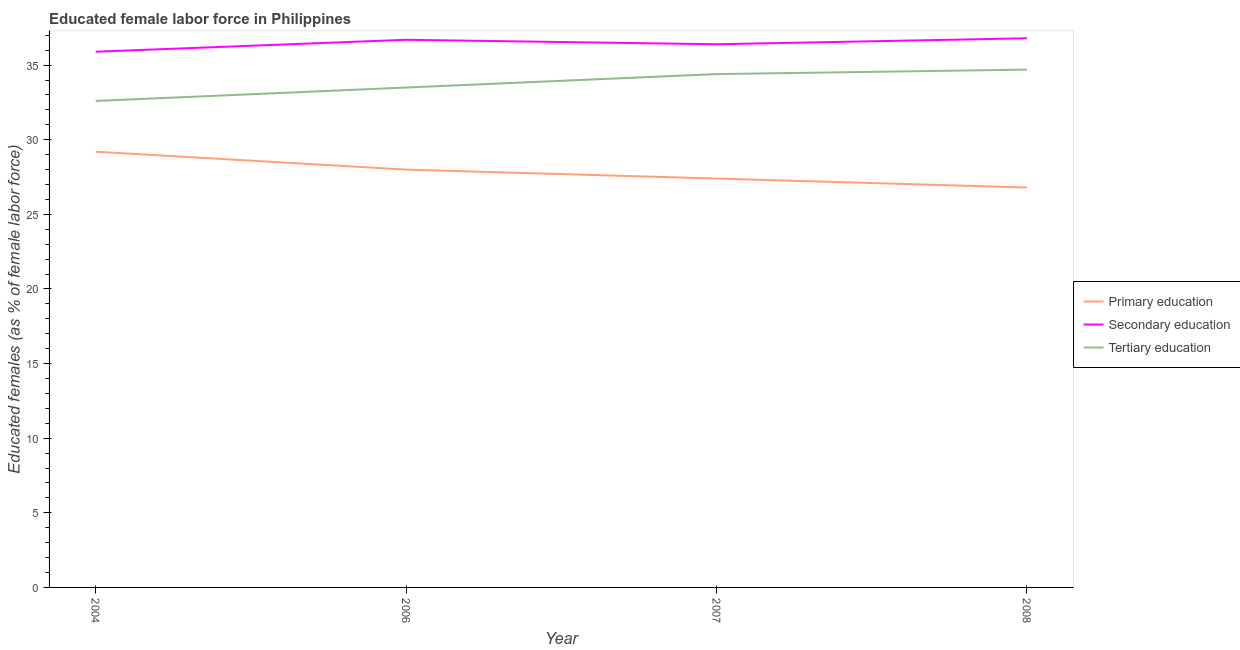Does the line corresponding to percentage of female labor force who received primary education intersect with the line corresponding to percentage of female labor force who received tertiary education?
Provide a short and direct response. No. What is the percentage of female labor force who received primary education in 2008?
Provide a succinct answer. 26.8. Across all years, what is the maximum percentage of female labor force who received secondary education?
Give a very brief answer. 36.8. Across all years, what is the minimum percentage of female labor force who received tertiary education?
Offer a very short reply. 32.6. What is the total percentage of female labor force who received secondary education in the graph?
Keep it short and to the point. 145.8. What is the difference between the percentage of female labor force who received secondary education in 2006 and that in 2008?
Keep it short and to the point. -0.1. What is the difference between the percentage of female labor force who received secondary education in 2007 and the percentage of female labor force who received tertiary education in 2006?
Provide a short and direct response. 2.9. What is the average percentage of female labor force who received tertiary education per year?
Offer a terse response. 33.8. In the year 2004, what is the difference between the percentage of female labor force who received secondary education and percentage of female labor force who received primary education?
Keep it short and to the point. 6.7. In how many years, is the percentage of female labor force who received secondary education greater than 29 %?
Provide a short and direct response. 4. What is the ratio of the percentage of female labor force who received primary education in 2006 to that in 2008?
Your response must be concise. 1.04. Is the difference between the percentage of female labor force who received primary education in 2006 and 2007 greater than the difference between the percentage of female labor force who received secondary education in 2006 and 2007?
Ensure brevity in your answer.  Yes. What is the difference between the highest and the second highest percentage of female labor force who received primary education?
Provide a short and direct response. 1.2. What is the difference between the highest and the lowest percentage of female labor force who received primary education?
Offer a terse response. 2.4. In how many years, is the percentage of female labor force who received primary education greater than the average percentage of female labor force who received primary education taken over all years?
Keep it short and to the point. 2. Is it the case that in every year, the sum of the percentage of female labor force who received primary education and percentage of female labor force who received secondary education is greater than the percentage of female labor force who received tertiary education?
Your answer should be very brief. Yes. Is the percentage of female labor force who received primary education strictly greater than the percentage of female labor force who received tertiary education over the years?
Give a very brief answer. No. Is the percentage of female labor force who received secondary education strictly less than the percentage of female labor force who received primary education over the years?
Ensure brevity in your answer.  No. Are the values on the major ticks of Y-axis written in scientific E-notation?
Offer a very short reply. No. Does the graph contain any zero values?
Ensure brevity in your answer.  No. How many legend labels are there?
Make the answer very short. 3. What is the title of the graph?
Keep it short and to the point. Educated female labor force in Philippines. What is the label or title of the X-axis?
Offer a terse response. Year. What is the label or title of the Y-axis?
Keep it short and to the point. Educated females (as % of female labor force). What is the Educated females (as % of female labor force) of Primary education in 2004?
Provide a succinct answer. 29.2. What is the Educated females (as % of female labor force) of Secondary education in 2004?
Provide a succinct answer. 35.9. What is the Educated females (as % of female labor force) in Tertiary education in 2004?
Offer a terse response. 32.6. What is the Educated females (as % of female labor force) in Secondary education in 2006?
Provide a succinct answer. 36.7. What is the Educated females (as % of female labor force) in Tertiary education in 2006?
Your answer should be very brief. 33.5. What is the Educated females (as % of female labor force) in Primary education in 2007?
Provide a short and direct response. 27.4. What is the Educated females (as % of female labor force) in Secondary education in 2007?
Make the answer very short. 36.4. What is the Educated females (as % of female labor force) in Tertiary education in 2007?
Your answer should be very brief. 34.4. What is the Educated females (as % of female labor force) in Primary education in 2008?
Provide a succinct answer. 26.8. What is the Educated females (as % of female labor force) in Secondary education in 2008?
Provide a short and direct response. 36.8. What is the Educated females (as % of female labor force) in Tertiary education in 2008?
Give a very brief answer. 34.7. Across all years, what is the maximum Educated females (as % of female labor force) in Primary education?
Ensure brevity in your answer.  29.2. Across all years, what is the maximum Educated females (as % of female labor force) of Secondary education?
Ensure brevity in your answer.  36.8. Across all years, what is the maximum Educated females (as % of female labor force) of Tertiary education?
Offer a very short reply. 34.7. Across all years, what is the minimum Educated females (as % of female labor force) in Primary education?
Give a very brief answer. 26.8. Across all years, what is the minimum Educated females (as % of female labor force) in Secondary education?
Provide a short and direct response. 35.9. Across all years, what is the minimum Educated females (as % of female labor force) of Tertiary education?
Ensure brevity in your answer.  32.6. What is the total Educated females (as % of female labor force) in Primary education in the graph?
Your response must be concise. 111.4. What is the total Educated females (as % of female labor force) of Secondary education in the graph?
Your response must be concise. 145.8. What is the total Educated females (as % of female labor force) of Tertiary education in the graph?
Ensure brevity in your answer.  135.2. What is the difference between the Educated females (as % of female labor force) of Primary education in 2004 and that in 2006?
Make the answer very short. 1.2. What is the difference between the Educated females (as % of female labor force) of Tertiary education in 2004 and that in 2006?
Give a very brief answer. -0.9. What is the difference between the Educated females (as % of female labor force) in Tertiary education in 2004 and that in 2007?
Make the answer very short. -1.8. What is the difference between the Educated females (as % of female labor force) in Tertiary education in 2004 and that in 2008?
Keep it short and to the point. -2.1. What is the difference between the Educated females (as % of female labor force) in Primary education in 2006 and that in 2007?
Give a very brief answer. 0.6. What is the difference between the Educated females (as % of female labor force) in Secondary education in 2006 and that in 2007?
Keep it short and to the point. 0.3. What is the difference between the Educated females (as % of female labor force) in Primary education in 2006 and that in 2008?
Keep it short and to the point. 1.2. What is the difference between the Educated females (as % of female labor force) in Tertiary education in 2006 and that in 2008?
Keep it short and to the point. -1.2. What is the difference between the Educated females (as % of female labor force) in Primary education in 2007 and that in 2008?
Your response must be concise. 0.6. What is the difference between the Educated females (as % of female labor force) of Secondary education in 2007 and that in 2008?
Your answer should be compact. -0.4. What is the difference between the Educated females (as % of female labor force) in Tertiary education in 2007 and that in 2008?
Your answer should be very brief. -0.3. What is the difference between the Educated females (as % of female labor force) of Primary education in 2004 and the Educated females (as % of female labor force) of Secondary education in 2006?
Give a very brief answer. -7.5. What is the difference between the Educated females (as % of female labor force) in Primary education in 2004 and the Educated females (as % of female labor force) in Tertiary education in 2007?
Your answer should be compact. -5.2. What is the difference between the Educated females (as % of female labor force) in Secondary education in 2004 and the Educated females (as % of female labor force) in Tertiary education in 2007?
Offer a terse response. 1.5. What is the difference between the Educated females (as % of female labor force) of Primary education in 2004 and the Educated females (as % of female labor force) of Tertiary education in 2008?
Provide a succinct answer. -5.5. What is the difference between the Educated females (as % of female labor force) in Secondary education in 2004 and the Educated females (as % of female labor force) in Tertiary education in 2008?
Your answer should be compact. 1.2. What is the difference between the Educated females (as % of female labor force) of Primary education in 2006 and the Educated females (as % of female labor force) of Secondary education in 2007?
Your answer should be very brief. -8.4. What is the difference between the Educated females (as % of female labor force) of Secondary education in 2006 and the Educated females (as % of female labor force) of Tertiary education in 2007?
Your response must be concise. 2.3. What is the difference between the Educated females (as % of female labor force) of Primary education in 2006 and the Educated females (as % of female labor force) of Secondary education in 2008?
Your answer should be compact. -8.8. What is the difference between the Educated females (as % of female labor force) in Primary education in 2007 and the Educated females (as % of female labor force) in Secondary education in 2008?
Make the answer very short. -9.4. What is the difference between the Educated females (as % of female labor force) in Primary education in 2007 and the Educated females (as % of female labor force) in Tertiary education in 2008?
Your answer should be compact. -7.3. What is the average Educated females (as % of female labor force) of Primary education per year?
Make the answer very short. 27.85. What is the average Educated females (as % of female labor force) of Secondary education per year?
Make the answer very short. 36.45. What is the average Educated females (as % of female labor force) of Tertiary education per year?
Offer a very short reply. 33.8. In the year 2004, what is the difference between the Educated females (as % of female labor force) of Primary education and Educated females (as % of female labor force) of Secondary education?
Your response must be concise. -6.7. In the year 2006, what is the difference between the Educated females (as % of female labor force) in Primary education and Educated females (as % of female labor force) in Secondary education?
Offer a terse response. -8.7. In the year 2006, what is the difference between the Educated females (as % of female labor force) of Primary education and Educated females (as % of female labor force) of Tertiary education?
Give a very brief answer. -5.5. In the year 2006, what is the difference between the Educated females (as % of female labor force) in Secondary education and Educated females (as % of female labor force) in Tertiary education?
Your response must be concise. 3.2. In the year 2007, what is the difference between the Educated females (as % of female labor force) of Primary education and Educated females (as % of female labor force) of Secondary education?
Offer a terse response. -9. In the year 2007, what is the difference between the Educated females (as % of female labor force) in Secondary education and Educated females (as % of female labor force) in Tertiary education?
Make the answer very short. 2. In the year 2008, what is the difference between the Educated females (as % of female labor force) of Primary education and Educated females (as % of female labor force) of Secondary education?
Your response must be concise. -10. In the year 2008, what is the difference between the Educated females (as % of female labor force) of Primary education and Educated females (as % of female labor force) of Tertiary education?
Give a very brief answer. -7.9. In the year 2008, what is the difference between the Educated females (as % of female labor force) in Secondary education and Educated females (as % of female labor force) in Tertiary education?
Offer a very short reply. 2.1. What is the ratio of the Educated females (as % of female labor force) of Primary education in 2004 to that in 2006?
Provide a short and direct response. 1.04. What is the ratio of the Educated females (as % of female labor force) of Secondary education in 2004 to that in 2006?
Your answer should be compact. 0.98. What is the ratio of the Educated females (as % of female labor force) of Tertiary education in 2004 to that in 2006?
Offer a very short reply. 0.97. What is the ratio of the Educated females (as % of female labor force) in Primary education in 2004 to that in 2007?
Offer a terse response. 1.07. What is the ratio of the Educated females (as % of female labor force) in Secondary education in 2004 to that in 2007?
Your answer should be compact. 0.99. What is the ratio of the Educated females (as % of female labor force) in Tertiary education in 2004 to that in 2007?
Offer a very short reply. 0.95. What is the ratio of the Educated females (as % of female labor force) in Primary education in 2004 to that in 2008?
Your response must be concise. 1.09. What is the ratio of the Educated females (as % of female labor force) of Secondary education in 2004 to that in 2008?
Your response must be concise. 0.98. What is the ratio of the Educated females (as % of female labor force) of Tertiary education in 2004 to that in 2008?
Offer a very short reply. 0.94. What is the ratio of the Educated females (as % of female labor force) in Primary education in 2006 to that in 2007?
Make the answer very short. 1.02. What is the ratio of the Educated females (as % of female labor force) of Secondary education in 2006 to that in 2007?
Your answer should be compact. 1.01. What is the ratio of the Educated females (as % of female labor force) of Tertiary education in 2006 to that in 2007?
Your answer should be compact. 0.97. What is the ratio of the Educated females (as % of female labor force) of Primary education in 2006 to that in 2008?
Ensure brevity in your answer.  1.04. What is the ratio of the Educated females (as % of female labor force) of Tertiary education in 2006 to that in 2008?
Your response must be concise. 0.97. What is the ratio of the Educated females (as % of female labor force) of Primary education in 2007 to that in 2008?
Your answer should be compact. 1.02. What is the ratio of the Educated females (as % of female labor force) in Secondary education in 2007 to that in 2008?
Your response must be concise. 0.99. What is the difference between the highest and the second highest Educated females (as % of female labor force) of Secondary education?
Your response must be concise. 0.1. What is the difference between the highest and the lowest Educated females (as % of female labor force) in Primary education?
Ensure brevity in your answer.  2.4. What is the difference between the highest and the lowest Educated females (as % of female labor force) in Secondary education?
Give a very brief answer. 0.9. What is the difference between the highest and the lowest Educated females (as % of female labor force) of Tertiary education?
Keep it short and to the point. 2.1. 